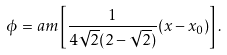<formula> <loc_0><loc_0><loc_500><loc_500>\phi = a m \left [ \frac { 1 } { 4 \sqrt { 2 } ( 2 - \sqrt { 2 } ) } ( x - x _ { 0 } ) \right ] .</formula> 